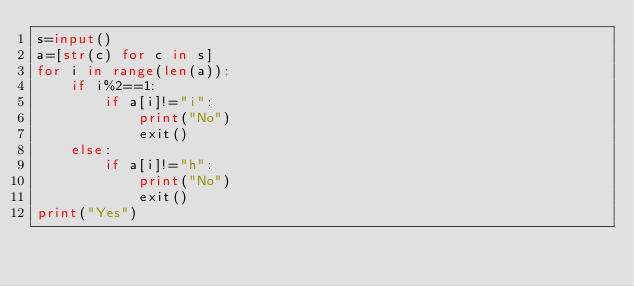<code> <loc_0><loc_0><loc_500><loc_500><_Python_>s=input()
a=[str(c) for c in s]
for i in range(len(a)):
    if i%2==1:
        if a[i]!="i":
            print("No")
            exit()
    else:
        if a[i]!="h":
            print("No")
            exit()
print("Yes")
</code> 